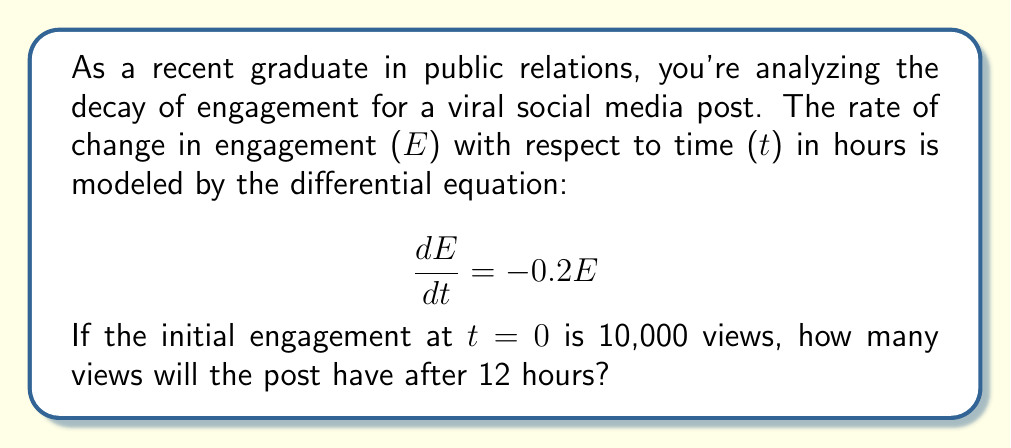Help me with this question. To solve this problem, we need to follow these steps:

1) First, we recognize that this is a first-order linear differential equation with constant coefficients. The general solution for such an equation is:

   $$E(t) = Ce^{kt}$$

   where C is a constant and k is the coefficient in the differential equation.

2) In our case, k = -0.2, so our general solution is:

   $$E(t) = Ce^{-0.2t}$$

3) To find C, we use the initial condition: E(0) = 10,000

   $$10,000 = Ce^{-0.2(0)} = C$$

4) So our particular solution is:

   $$E(t) = 10,000e^{-0.2t}$$

5) Now we can find E(12) by plugging in t = 12:

   $$E(12) = 10,000e^{-0.2(12)}$$

6) Using a calculator or computer:

   $$E(12) = 10,000e^{-2.4} \approx 906.61$$

7) Since we're dealing with views, we round down to the nearest whole number.
Answer: 906 views 